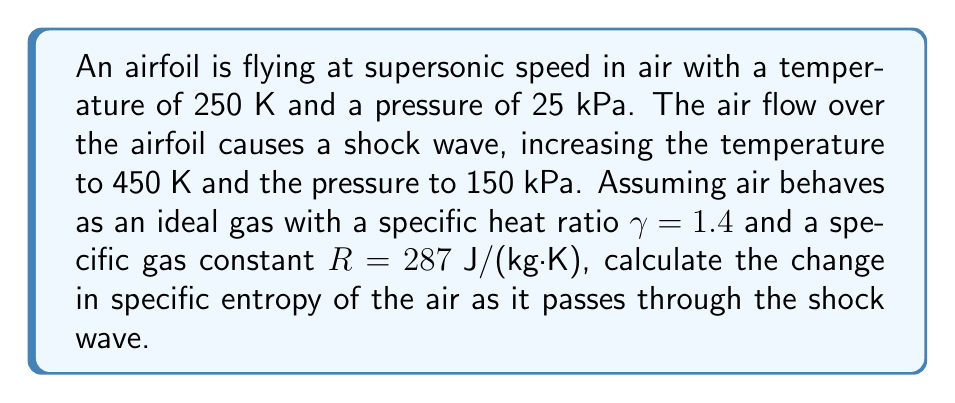Help me with this question. To calculate the change in specific entropy, we'll use the following steps:

1) For an ideal gas, the change in specific entropy is given by:

   $$\Delta s = c_p \ln\left(\frac{T_2}{T_1}\right) - R \ln\left(\frac{P_2}{P_1}\right)$$

   where $c_p$ is the specific heat capacity at constant pressure.

2) We know that for an ideal gas, $c_p = \frac{\gamma R}{\gamma - 1}$. Let's calculate this:

   $$c_p = \frac{1.4 \cdot 287}{1.4 - 1} = 1004.5 \text{ J/(kg·K)}$$

3) Now, let's substitute all known values into the entropy change equation:

   $$\Delta s = 1004.5 \ln\left(\frac{450}{250}\right) - 287 \ln\left(\frac{150000}{25000}\right)$$

4) Simplify:

   $$\Delta s = 1004.5 \ln(1.8) - 287 \ln(6)$$

5) Calculate:

   $$\Delta s = 1004.5 \cdot 0.5878 - 287 \cdot 1.7918$$

   $$\Delta s = 590.4441 - 514.2466$$

   $$\Delta s = 76.1975 \text{ J/(kg·K)}$$

Thus, the specific entropy of the air increases by approximately 76.2 J/(kg·K) as it passes through the shock wave.
Answer: 76.2 J/(kg·K) 